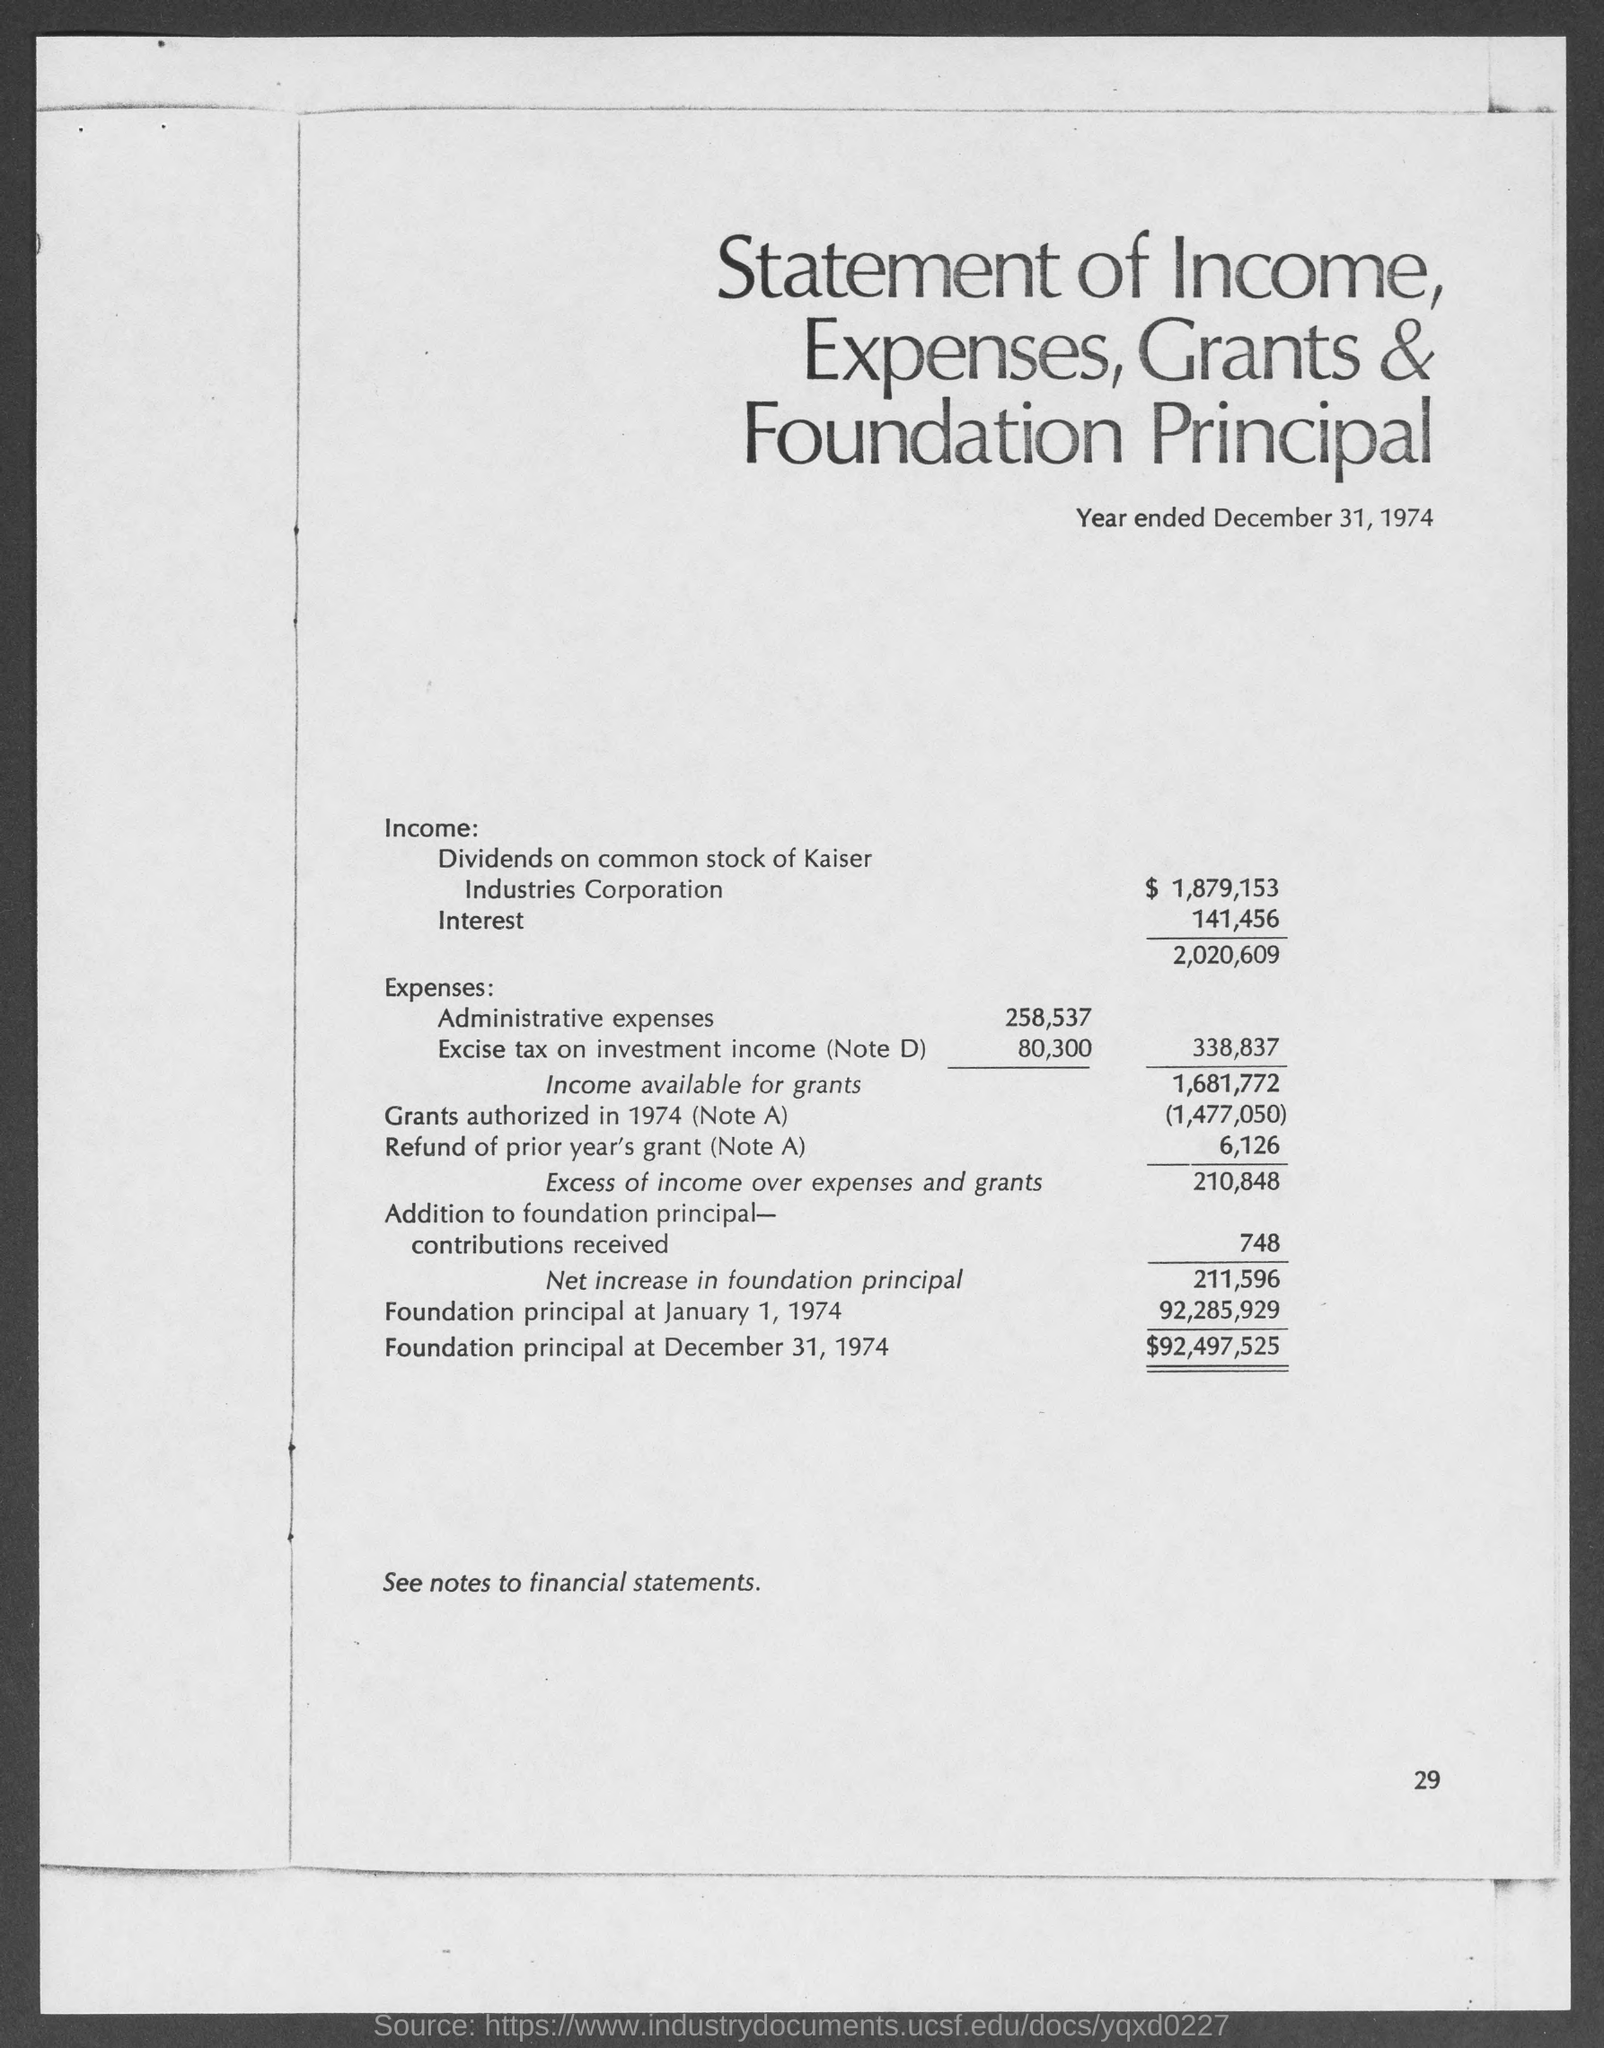Indicate a few pertinent items in this graphic. The amount of Foundation principal at the beginning of 1974 was 92,285,929. The amount of interest is 141,456. The heading of the document is "Statement of Income, Expenses, Grants & Foundation Principal. 